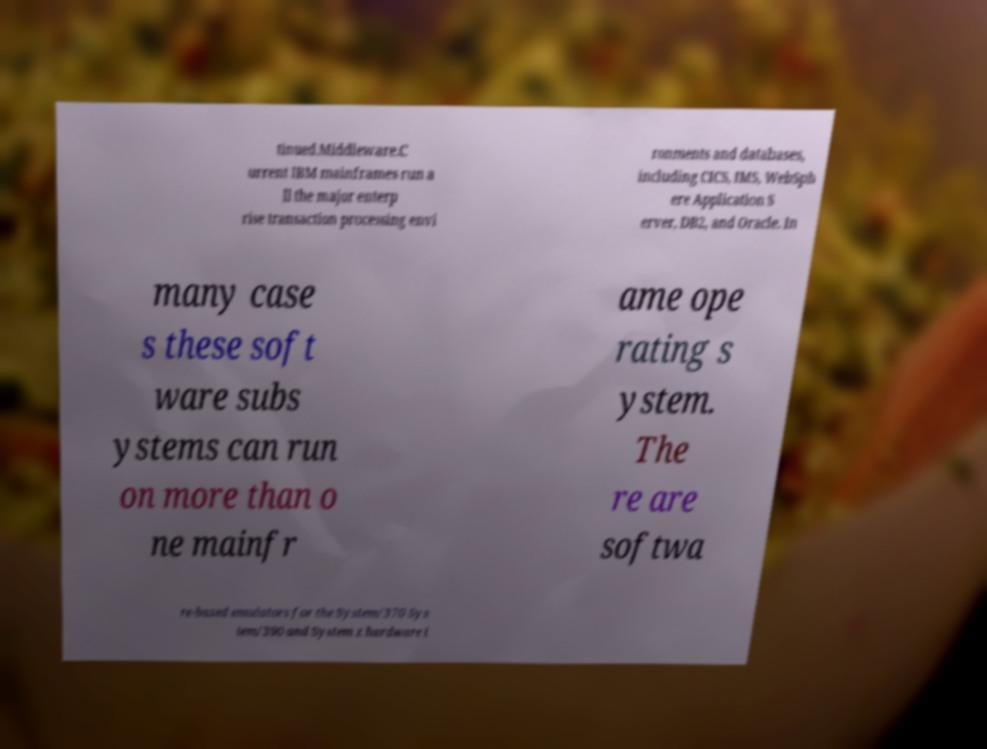I need the written content from this picture converted into text. Can you do that? tinued.Middleware.C urrent IBM mainframes run a ll the major enterp rise transaction processing envi ronments and databases, including CICS, IMS, WebSph ere Application S erver, DB2, and Oracle. In many case s these soft ware subs ystems can run on more than o ne mainfr ame ope rating s ystem. The re are softwa re-based emulators for the System/370 Sys tem/390 and System z hardware i 